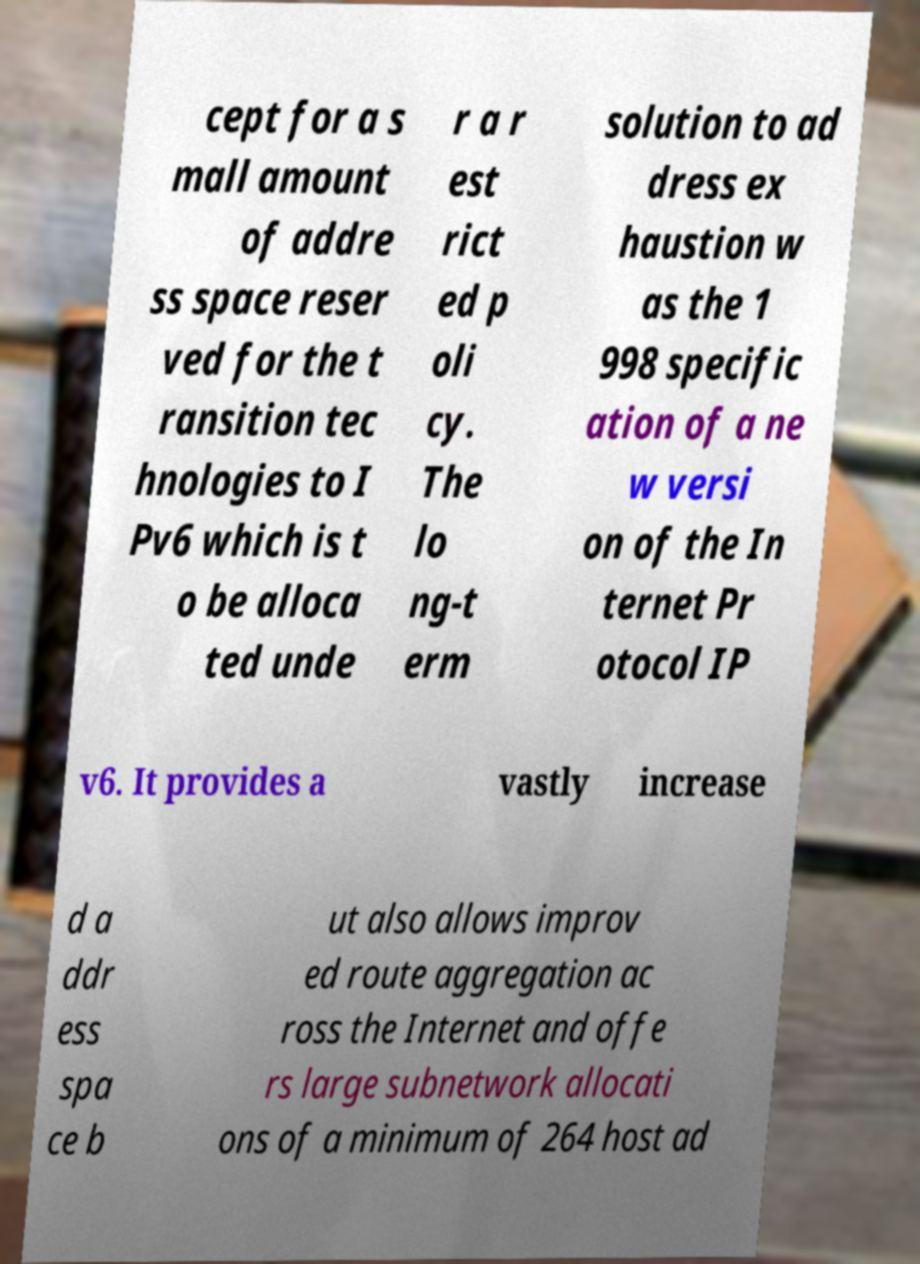Can you read and provide the text displayed in the image?This photo seems to have some interesting text. Can you extract and type it out for me? cept for a s mall amount of addre ss space reser ved for the t ransition tec hnologies to I Pv6 which is t o be alloca ted unde r a r est rict ed p oli cy. The lo ng-t erm solution to ad dress ex haustion w as the 1 998 specific ation of a ne w versi on of the In ternet Pr otocol IP v6. It provides a vastly increase d a ddr ess spa ce b ut also allows improv ed route aggregation ac ross the Internet and offe rs large subnetwork allocati ons of a minimum of 264 host ad 